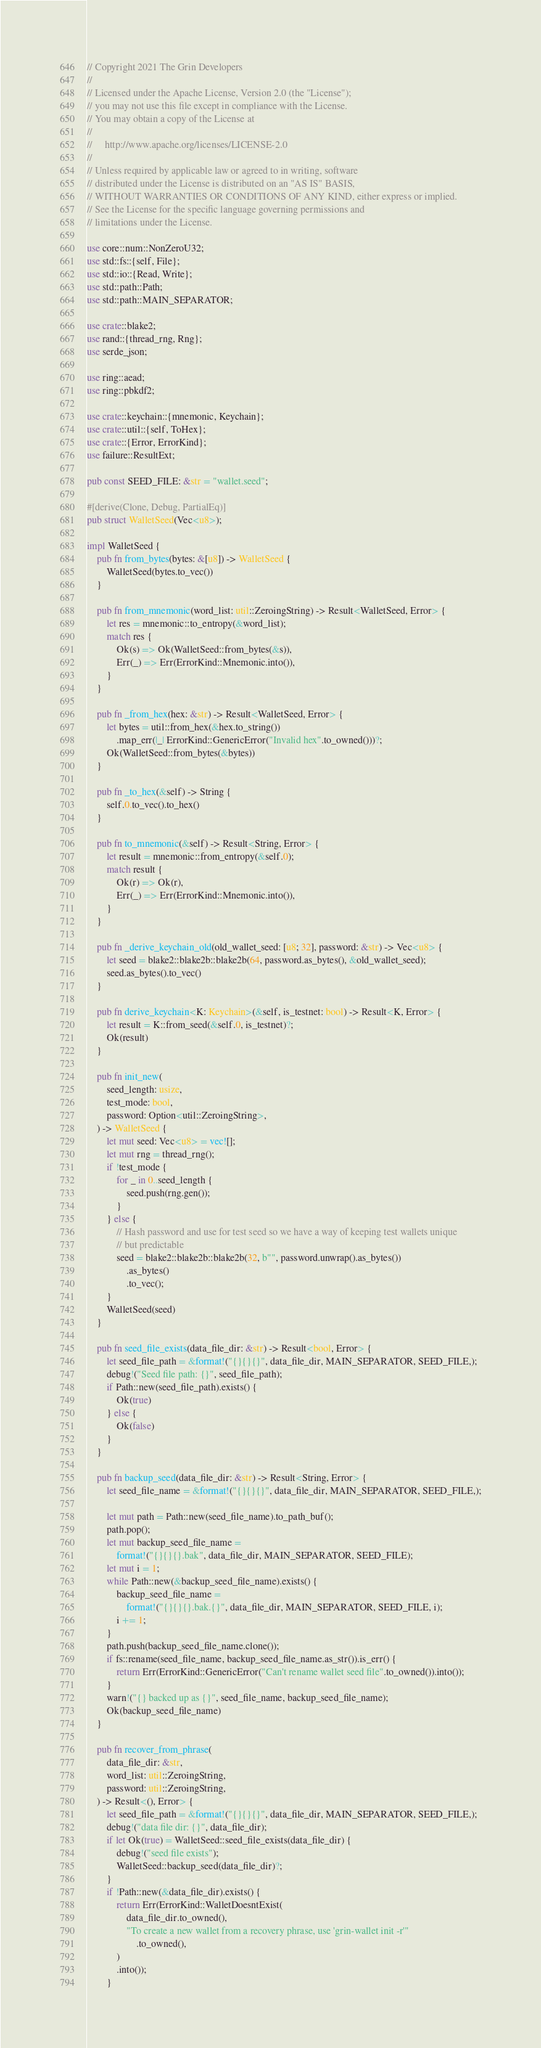Convert code to text. <code><loc_0><loc_0><loc_500><loc_500><_Rust_>// Copyright 2021 The Grin Developers
//
// Licensed under the Apache License, Version 2.0 (the "License");
// you may not use this file except in compliance with the License.
// You may obtain a copy of the License at
//
//     http://www.apache.org/licenses/LICENSE-2.0
//
// Unless required by applicable law or agreed to in writing, software
// distributed under the License is distributed on an "AS IS" BASIS,
// WITHOUT WARRANTIES OR CONDITIONS OF ANY KIND, either express or implied.
// See the License for the specific language governing permissions and
// limitations under the License.

use core::num::NonZeroU32;
use std::fs::{self, File};
use std::io::{Read, Write};
use std::path::Path;
use std::path::MAIN_SEPARATOR;

use crate::blake2;
use rand::{thread_rng, Rng};
use serde_json;

use ring::aead;
use ring::pbkdf2;

use crate::keychain::{mnemonic, Keychain};
use crate::util::{self, ToHex};
use crate::{Error, ErrorKind};
use failure::ResultExt;

pub const SEED_FILE: &str = "wallet.seed";

#[derive(Clone, Debug, PartialEq)]
pub struct WalletSeed(Vec<u8>);

impl WalletSeed {
	pub fn from_bytes(bytes: &[u8]) -> WalletSeed {
		WalletSeed(bytes.to_vec())
	}

	pub fn from_mnemonic(word_list: util::ZeroingString) -> Result<WalletSeed, Error> {
		let res = mnemonic::to_entropy(&word_list);
		match res {
			Ok(s) => Ok(WalletSeed::from_bytes(&s)),
			Err(_) => Err(ErrorKind::Mnemonic.into()),
		}
	}

	pub fn _from_hex(hex: &str) -> Result<WalletSeed, Error> {
		let bytes = util::from_hex(&hex.to_string())
			.map_err(|_| ErrorKind::GenericError("Invalid hex".to_owned()))?;
		Ok(WalletSeed::from_bytes(&bytes))
	}

	pub fn _to_hex(&self) -> String {
		self.0.to_vec().to_hex()
	}

	pub fn to_mnemonic(&self) -> Result<String, Error> {
		let result = mnemonic::from_entropy(&self.0);
		match result {
			Ok(r) => Ok(r),
			Err(_) => Err(ErrorKind::Mnemonic.into()),
		}
	}

	pub fn _derive_keychain_old(old_wallet_seed: [u8; 32], password: &str) -> Vec<u8> {
		let seed = blake2::blake2b::blake2b(64, password.as_bytes(), &old_wallet_seed);
		seed.as_bytes().to_vec()
	}

	pub fn derive_keychain<K: Keychain>(&self, is_testnet: bool) -> Result<K, Error> {
		let result = K::from_seed(&self.0, is_testnet)?;
		Ok(result)
	}

	pub fn init_new(
		seed_length: usize,
		test_mode: bool,
		password: Option<util::ZeroingString>,
	) -> WalletSeed {
		let mut seed: Vec<u8> = vec![];
		let mut rng = thread_rng();
		if !test_mode {
			for _ in 0..seed_length {
				seed.push(rng.gen());
			}
		} else {
			// Hash password and use for test seed so we have a way of keeping test wallets unique
			// but predictable
			seed = blake2::blake2b::blake2b(32, b"", password.unwrap().as_bytes())
				.as_bytes()
				.to_vec();
		}
		WalletSeed(seed)
	}

	pub fn seed_file_exists(data_file_dir: &str) -> Result<bool, Error> {
		let seed_file_path = &format!("{}{}{}", data_file_dir, MAIN_SEPARATOR, SEED_FILE,);
		debug!("Seed file path: {}", seed_file_path);
		if Path::new(seed_file_path).exists() {
			Ok(true)
		} else {
			Ok(false)
		}
	}

	pub fn backup_seed(data_file_dir: &str) -> Result<String, Error> {
		let seed_file_name = &format!("{}{}{}", data_file_dir, MAIN_SEPARATOR, SEED_FILE,);

		let mut path = Path::new(seed_file_name).to_path_buf();
		path.pop();
		let mut backup_seed_file_name =
			format!("{}{}{}.bak", data_file_dir, MAIN_SEPARATOR, SEED_FILE);
		let mut i = 1;
		while Path::new(&backup_seed_file_name).exists() {
			backup_seed_file_name =
				format!("{}{}{}.bak.{}", data_file_dir, MAIN_SEPARATOR, SEED_FILE, i);
			i += 1;
		}
		path.push(backup_seed_file_name.clone());
		if fs::rename(seed_file_name, backup_seed_file_name.as_str()).is_err() {
			return Err(ErrorKind::GenericError("Can't rename wallet seed file".to_owned()).into());
		}
		warn!("{} backed up as {}", seed_file_name, backup_seed_file_name);
		Ok(backup_seed_file_name)
	}

	pub fn recover_from_phrase(
		data_file_dir: &str,
		word_list: util::ZeroingString,
		password: util::ZeroingString,
	) -> Result<(), Error> {
		let seed_file_path = &format!("{}{}{}", data_file_dir, MAIN_SEPARATOR, SEED_FILE,);
		debug!("data file dir: {}", data_file_dir);
		if let Ok(true) = WalletSeed::seed_file_exists(data_file_dir) {
			debug!("seed file exists");
			WalletSeed::backup_seed(data_file_dir)?;
		}
		if !Path::new(&data_file_dir).exists() {
			return Err(ErrorKind::WalletDoesntExist(
				data_file_dir.to_owned(),
				"To create a new wallet from a recovery phrase, use 'grin-wallet init -r'"
					.to_owned(),
			)
			.into());
		}</code> 